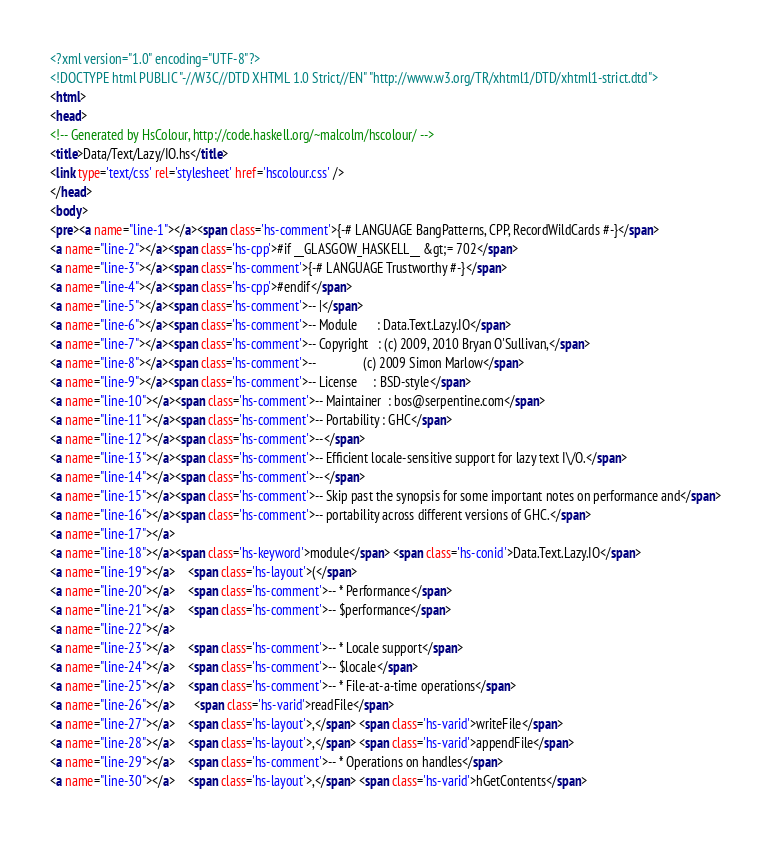<code> <loc_0><loc_0><loc_500><loc_500><_HTML_><?xml version="1.0" encoding="UTF-8"?>
<!DOCTYPE html PUBLIC "-//W3C//DTD XHTML 1.0 Strict//EN" "http://www.w3.org/TR/xhtml1/DTD/xhtml1-strict.dtd">
<html>
<head>
<!-- Generated by HsColour, http://code.haskell.org/~malcolm/hscolour/ -->
<title>Data/Text/Lazy/IO.hs</title>
<link type='text/css' rel='stylesheet' href='hscolour.css' />
</head>
<body>
<pre><a name="line-1"></a><span class='hs-comment'>{-# LANGUAGE BangPatterns, CPP, RecordWildCards #-}</span>
<a name="line-2"></a><span class='hs-cpp'>#if __GLASGOW_HASKELL__ &gt;= 702</span>
<a name="line-3"></a><span class='hs-comment'>{-# LANGUAGE Trustworthy #-}</span>
<a name="line-4"></a><span class='hs-cpp'>#endif</span>
<a name="line-5"></a><span class='hs-comment'>-- |</span>
<a name="line-6"></a><span class='hs-comment'>-- Module      : Data.Text.Lazy.IO</span>
<a name="line-7"></a><span class='hs-comment'>-- Copyright   : (c) 2009, 2010 Bryan O'Sullivan,</span>
<a name="line-8"></a><span class='hs-comment'>--               (c) 2009 Simon Marlow</span>
<a name="line-9"></a><span class='hs-comment'>-- License     : BSD-style</span>
<a name="line-10"></a><span class='hs-comment'>-- Maintainer  : bos@serpentine.com</span>
<a name="line-11"></a><span class='hs-comment'>-- Portability : GHC</span>
<a name="line-12"></a><span class='hs-comment'>--</span>
<a name="line-13"></a><span class='hs-comment'>-- Efficient locale-sensitive support for lazy text I\/O.</span>
<a name="line-14"></a><span class='hs-comment'>--</span>
<a name="line-15"></a><span class='hs-comment'>-- Skip past the synopsis for some important notes on performance and</span>
<a name="line-16"></a><span class='hs-comment'>-- portability across different versions of GHC.</span>
<a name="line-17"></a>
<a name="line-18"></a><span class='hs-keyword'>module</span> <span class='hs-conid'>Data.Text.Lazy.IO</span>
<a name="line-19"></a>    <span class='hs-layout'>(</span>
<a name="line-20"></a>    <span class='hs-comment'>-- * Performance</span>
<a name="line-21"></a>    <span class='hs-comment'>-- $performance</span>
<a name="line-22"></a>
<a name="line-23"></a>    <span class='hs-comment'>-- * Locale support</span>
<a name="line-24"></a>    <span class='hs-comment'>-- $locale</span>
<a name="line-25"></a>    <span class='hs-comment'>-- * File-at-a-time operations</span>
<a name="line-26"></a>      <span class='hs-varid'>readFile</span>
<a name="line-27"></a>    <span class='hs-layout'>,</span> <span class='hs-varid'>writeFile</span>
<a name="line-28"></a>    <span class='hs-layout'>,</span> <span class='hs-varid'>appendFile</span>
<a name="line-29"></a>    <span class='hs-comment'>-- * Operations on handles</span>
<a name="line-30"></a>    <span class='hs-layout'>,</span> <span class='hs-varid'>hGetContents</span></code> 